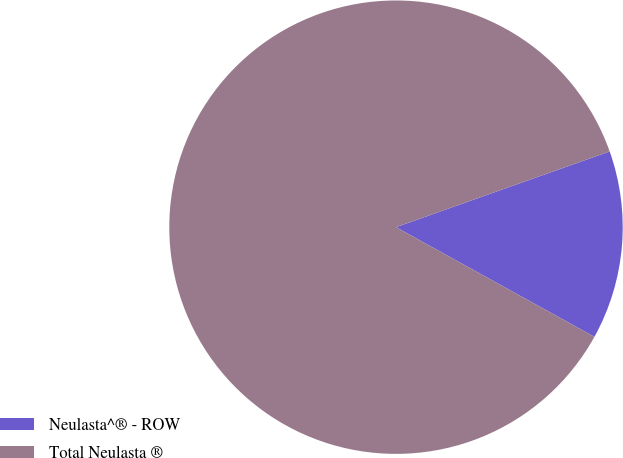Convert chart. <chart><loc_0><loc_0><loc_500><loc_500><pie_chart><fcel>Neulasta^® - ROW<fcel>Total Neulasta ®<nl><fcel>13.46%<fcel>86.54%<nl></chart> 